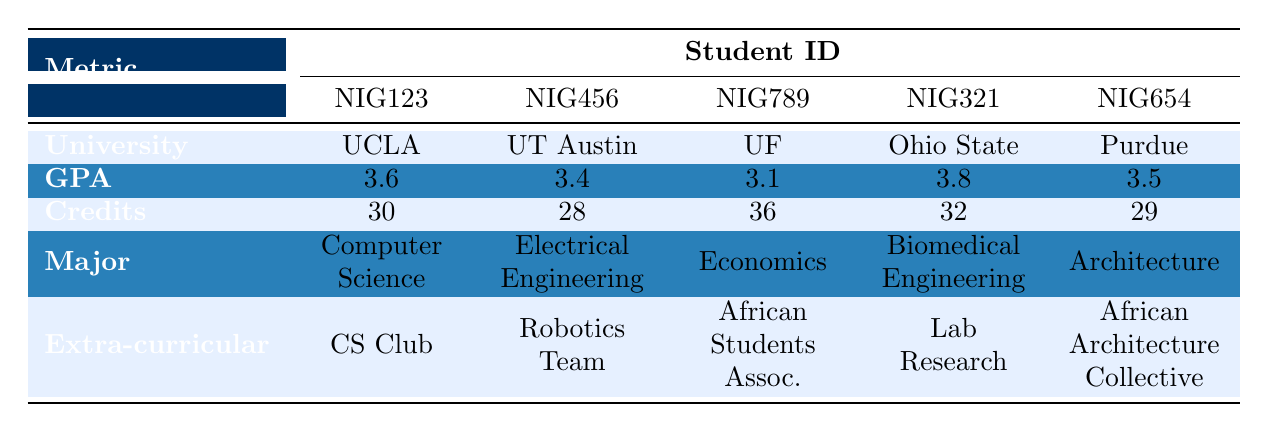What is the GPA of the student from Purdue University? The table shows that the student ID for Purdue University is NIG654, and the corresponding GPA listed is 3.5.
Answer: 3.5 Which major has the highest GPA among the students? Looking at the GPA data, NIG321 has the highest GPA at 3.8, and their major is Biomedical Engineering.
Answer: Biomedical Engineering How many credits did the University of Florida student complete? The entry for the University of Florida under student ID NIG789 indicates that this student completed 36 credits.
Answer: 36 Is there a student who is a member of both a club and an association? Checking the extra-curricular involvement for each student, NIG789 is a volunteer at the African Students Association but no student is mentioned as being part of both a club and an association; therefore, the answer is no.
Answer: No What is the average GPA of all Nigerian students listed in the table? Adding the GPAs together: (3.6 + 3.4 + 3.1 + 3.8 + 3.5) = 17.4. There are 5 students, so the average is 17.4 / 5 = 3.48.
Answer: 3.48 Which university has a student with the most credits completed? The table shows that the student from the University of Florida (NIG789) has completed 36 credits, which is the highest among all listed universities.
Answer: University of Florida How many students are involved in extra-curricular activities related to engineering? Two students (NIG456 from UT Austin in Electrical Engineering and NIG321 from Ohio State in Biomedical Engineering) are identified as participating in activities relevant to engineering, indicating that they are involved in engineering-related extra-curricular activities.
Answer: 2 Is there a student who has a GPA lower than 3.2? By examining the GPAs listed, NIG789 has a GPA of 3.1, which is lower than 3.2. Therefore, there is a student with a GPA less than 3.2.
Answer: Yes What is the difference in GPA between the highest and lowest-performing student? The highest GPA is 3.8 (NIG321) and the lowest is 3.1 (NIG789). The difference is 3.8 - 3.1 = 0.7, which represents the gap in academic performance.
Answer: 0.7 